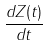Convert formula to latex. <formula><loc_0><loc_0><loc_500><loc_500>\frac { d Z ( t ) } { d t }</formula> 